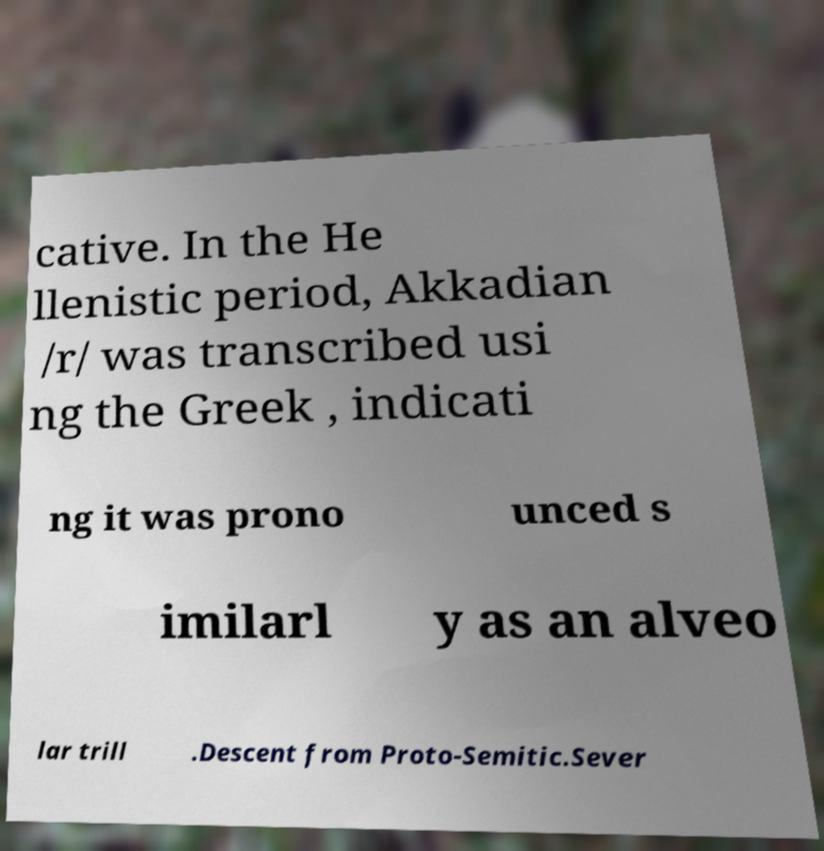For documentation purposes, I need the text within this image transcribed. Could you provide that? cative. In the He llenistic period, Akkadian /r/ was transcribed usi ng the Greek , indicati ng it was prono unced s imilarl y as an alveo lar trill .Descent from Proto-Semitic.Sever 